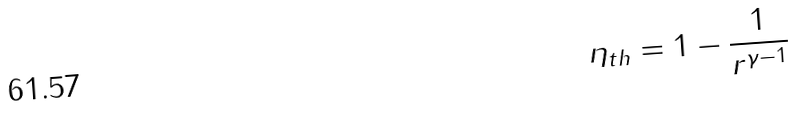Convert formula to latex. <formula><loc_0><loc_0><loc_500><loc_500>\eta _ { t h } = 1 - { \frac { 1 } { r ^ { \gamma - 1 } } }</formula> 